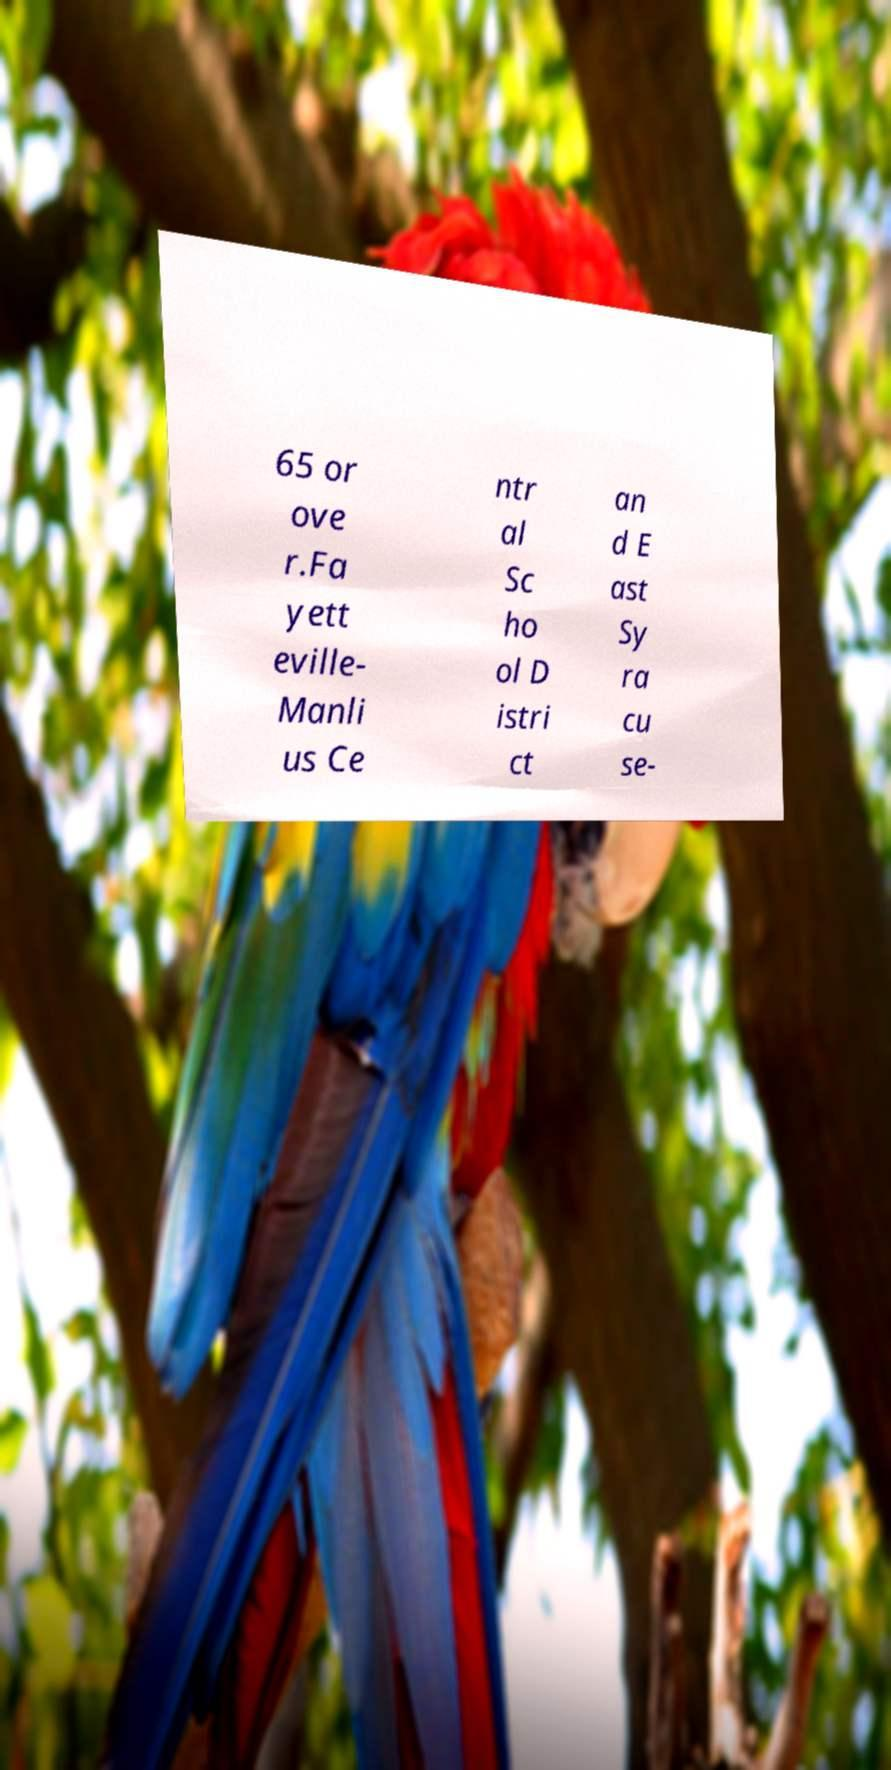Please identify and transcribe the text found in this image. 65 or ove r.Fa yett eville- Manli us Ce ntr al Sc ho ol D istri ct an d E ast Sy ra cu se- 